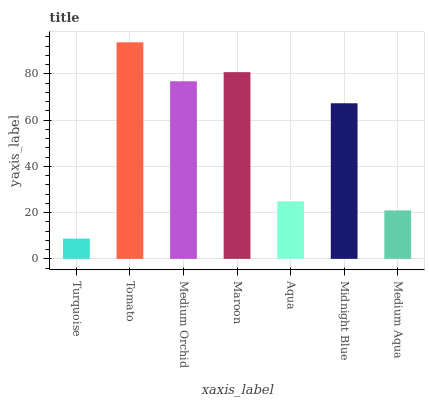Is Turquoise the minimum?
Answer yes or no. Yes. Is Tomato the maximum?
Answer yes or no. Yes. Is Medium Orchid the minimum?
Answer yes or no. No. Is Medium Orchid the maximum?
Answer yes or no. No. Is Tomato greater than Medium Orchid?
Answer yes or no. Yes. Is Medium Orchid less than Tomato?
Answer yes or no. Yes. Is Medium Orchid greater than Tomato?
Answer yes or no. No. Is Tomato less than Medium Orchid?
Answer yes or no. No. Is Midnight Blue the high median?
Answer yes or no. Yes. Is Midnight Blue the low median?
Answer yes or no. Yes. Is Maroon the high median?
Answer yes or no. No. Is Tomato the low median?
Answer yes or no. No. 